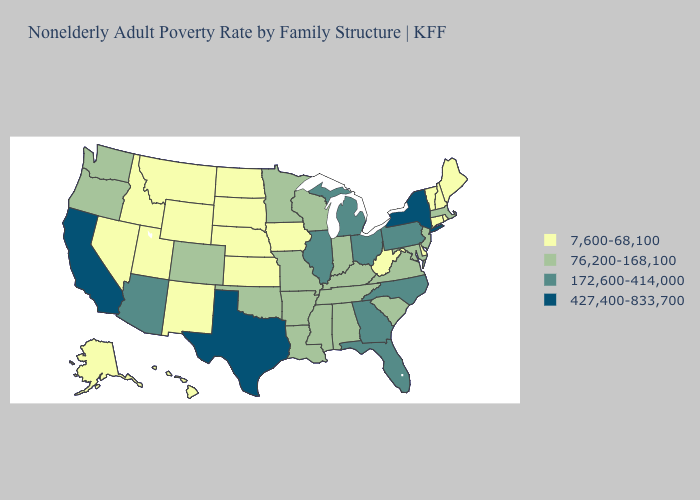What is the value of Alabama?
Quick response, please. 76,200-168,100. Does Ohio have the same value as Pennsylvania?
Short answer required. Yes. What is the lowest value in states that border Kentucky?
Give a very brief answer. 7,600-68,100. What is the highest value in states that border New York?
Keep it brief. 172,600-414,000. What is the value of Georgia?
Write a very short answer. 172,600-414,000. What is the value of Wyoming?
Keep it brief. 7,600-68,100. Among the states that border Kentucky , does West Virginia have the lowest value?
Write a very short answer. Yes. Name the states that have a value in the range 427,400-833,700?
Short answer required. California, New York, Texas. How many symbols are there in the legend?
Answer briefly. 4. Does Iowa have the highest value in the USA?
Short answer required. No. Does the map have missing data?
Be succinct. No. Does New Jersey have the lowest value in the Northeast?
Keep it brief. No. Which states have the highest value in the USA?
Short answer required. California, New York, Texas. Among the states that border Virginia , does North Carolina have the highest value?
Short answer required. Yes. Among the states that border Virginia , does West Virginia have the lowest value?
Keep it brief. Yes. 